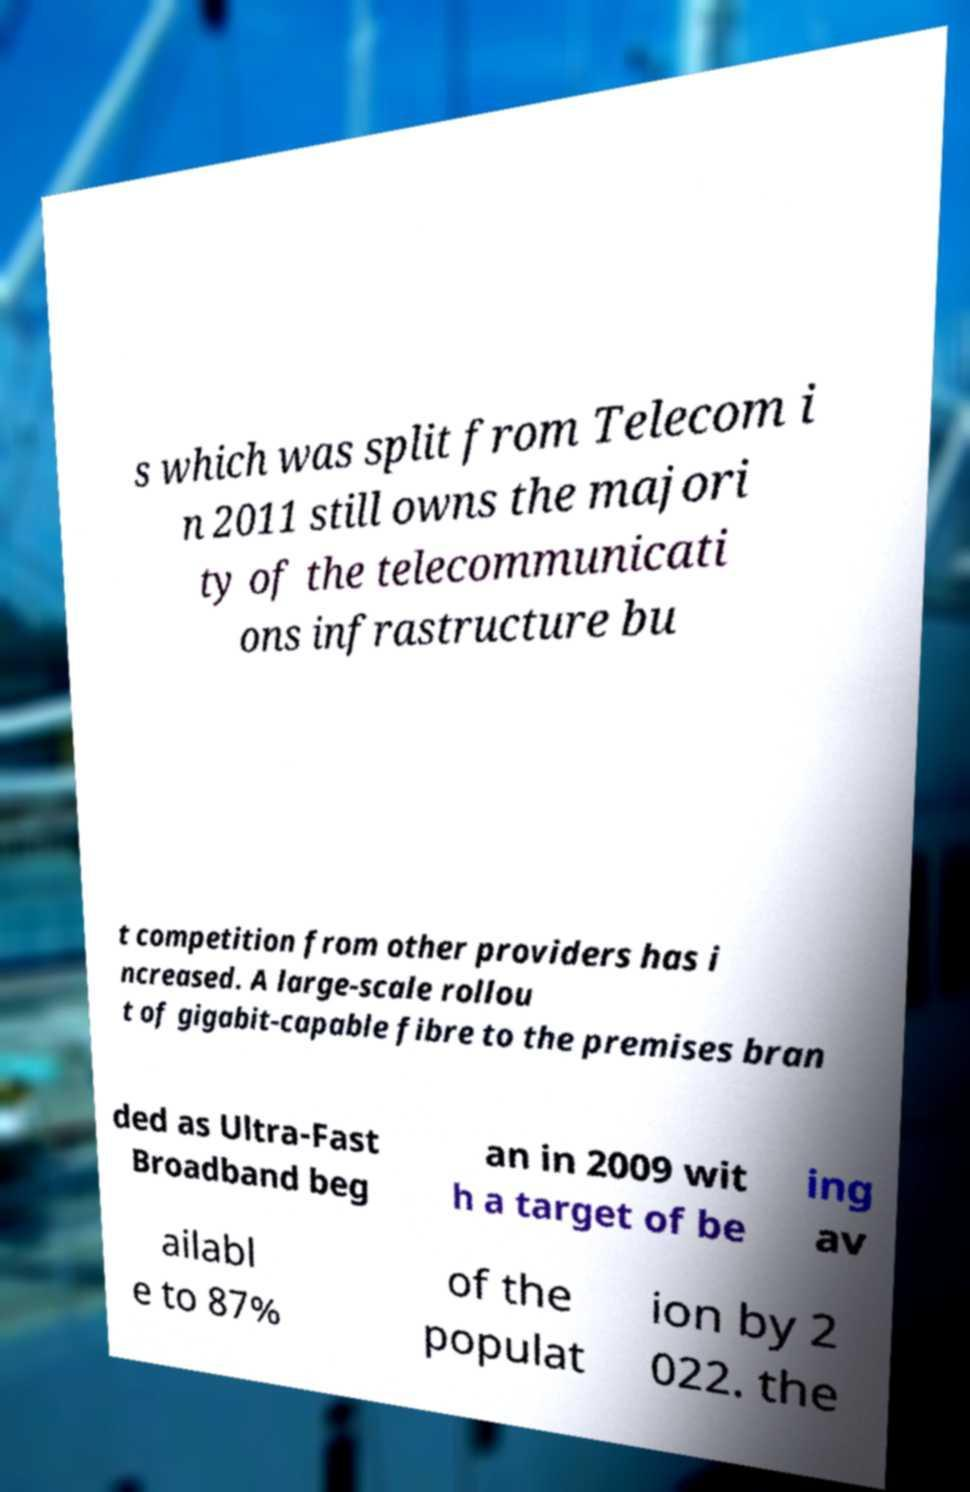Please identify and transcribe the text found in this image. s which was split from Telecom i n 2011 still owns the majori ty of the telecommunicati ons infrastructure bu t competition from other providers has i ncreased. A large-scale rollou t of gigabit-capable fibre to the premises bran ded as Ultra-Fast Broadband beg an in 2009 wit h a target of be ing av ailabl e to 87% of the populat ion by 2 022. the 